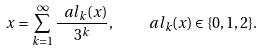<formula> <loc_0><loc_0><loc_500><loc_500>x = \sum _ { k = 1 } ^ { \infty } \frac { \ a l _ { k } ( x ) } { 3 ^ { k } } , \quad \ a l _ { k } ( x ) \in \{ 0 , 1 , 2 \} .</formula> 